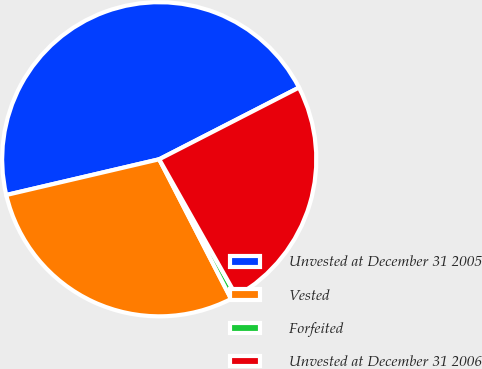Convert chart to OTSL. <chart><loc_0><loc_0><loc_500><loc_500><pie_chart><fcel>Unvested at December 31 2005<fcel>Vested<fcel>Forfeited<fcel>Unvested at December 31 2006<nl><fcel>46.11%<fcel>28.91%<fcel>0.62%<fcel>24.36%<nl></chart> 